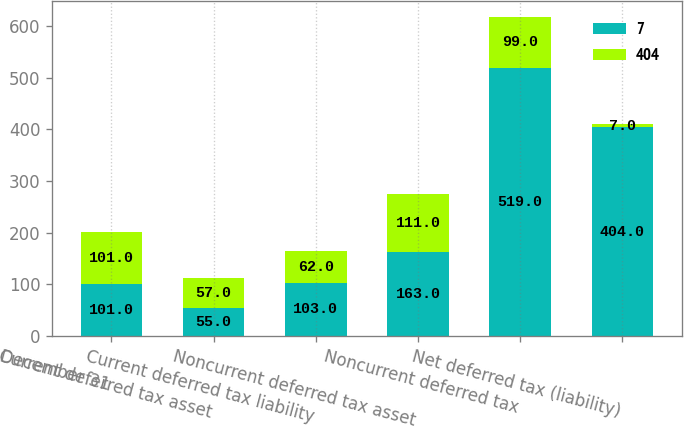<chart> <loc_0><loc_0><loc_500><loc_500><stacked_bar_chart><ecel><fcel>December 31<fcel>Current deferred tax asset<fcel>Current deferred tax liability<fcel>Noncurrent deferred tax asset<fcel>Noncurrent deferred tax<fcel>Net deferred tax (liability)<nl><fcel>7<fcel>101<fcel>55<fcel>103<fcel>163<fcel>519<fcel>404<nl><fcel>404<fcel>101<fcel>57<fcel>62<fcel>111<fcel>99<fcel>7<nl></chart> 